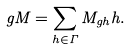Convert formula to latex. <formula><loc_0><loc_0><loc_500><loc_500>g M = \sum _ { h \in \Gamma } M _ { g h } h .</formula> 